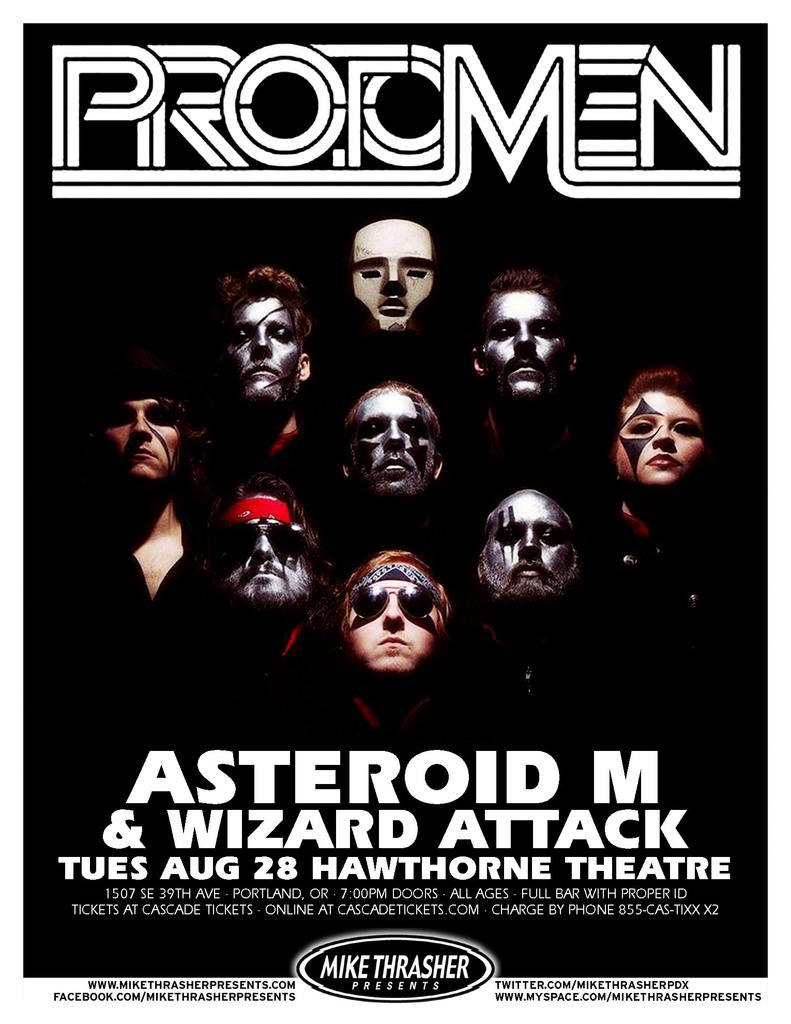<image>
Relay a brief, clear account of the picture shown. A poster for Protomen at the Hawthorne Theatre. 